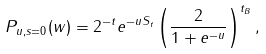Convert formula to latex. <formula><loc_0><loc_0><loc_500><loc_500>P _ { u , s = 0 } ( w ) = 2 ^ { - t } e ^ { - u S _ { t } } \left ( \frac { 2 } { 1 + e ^ { - u } } \right ) ^ { t _ { B } } ,</formula> 